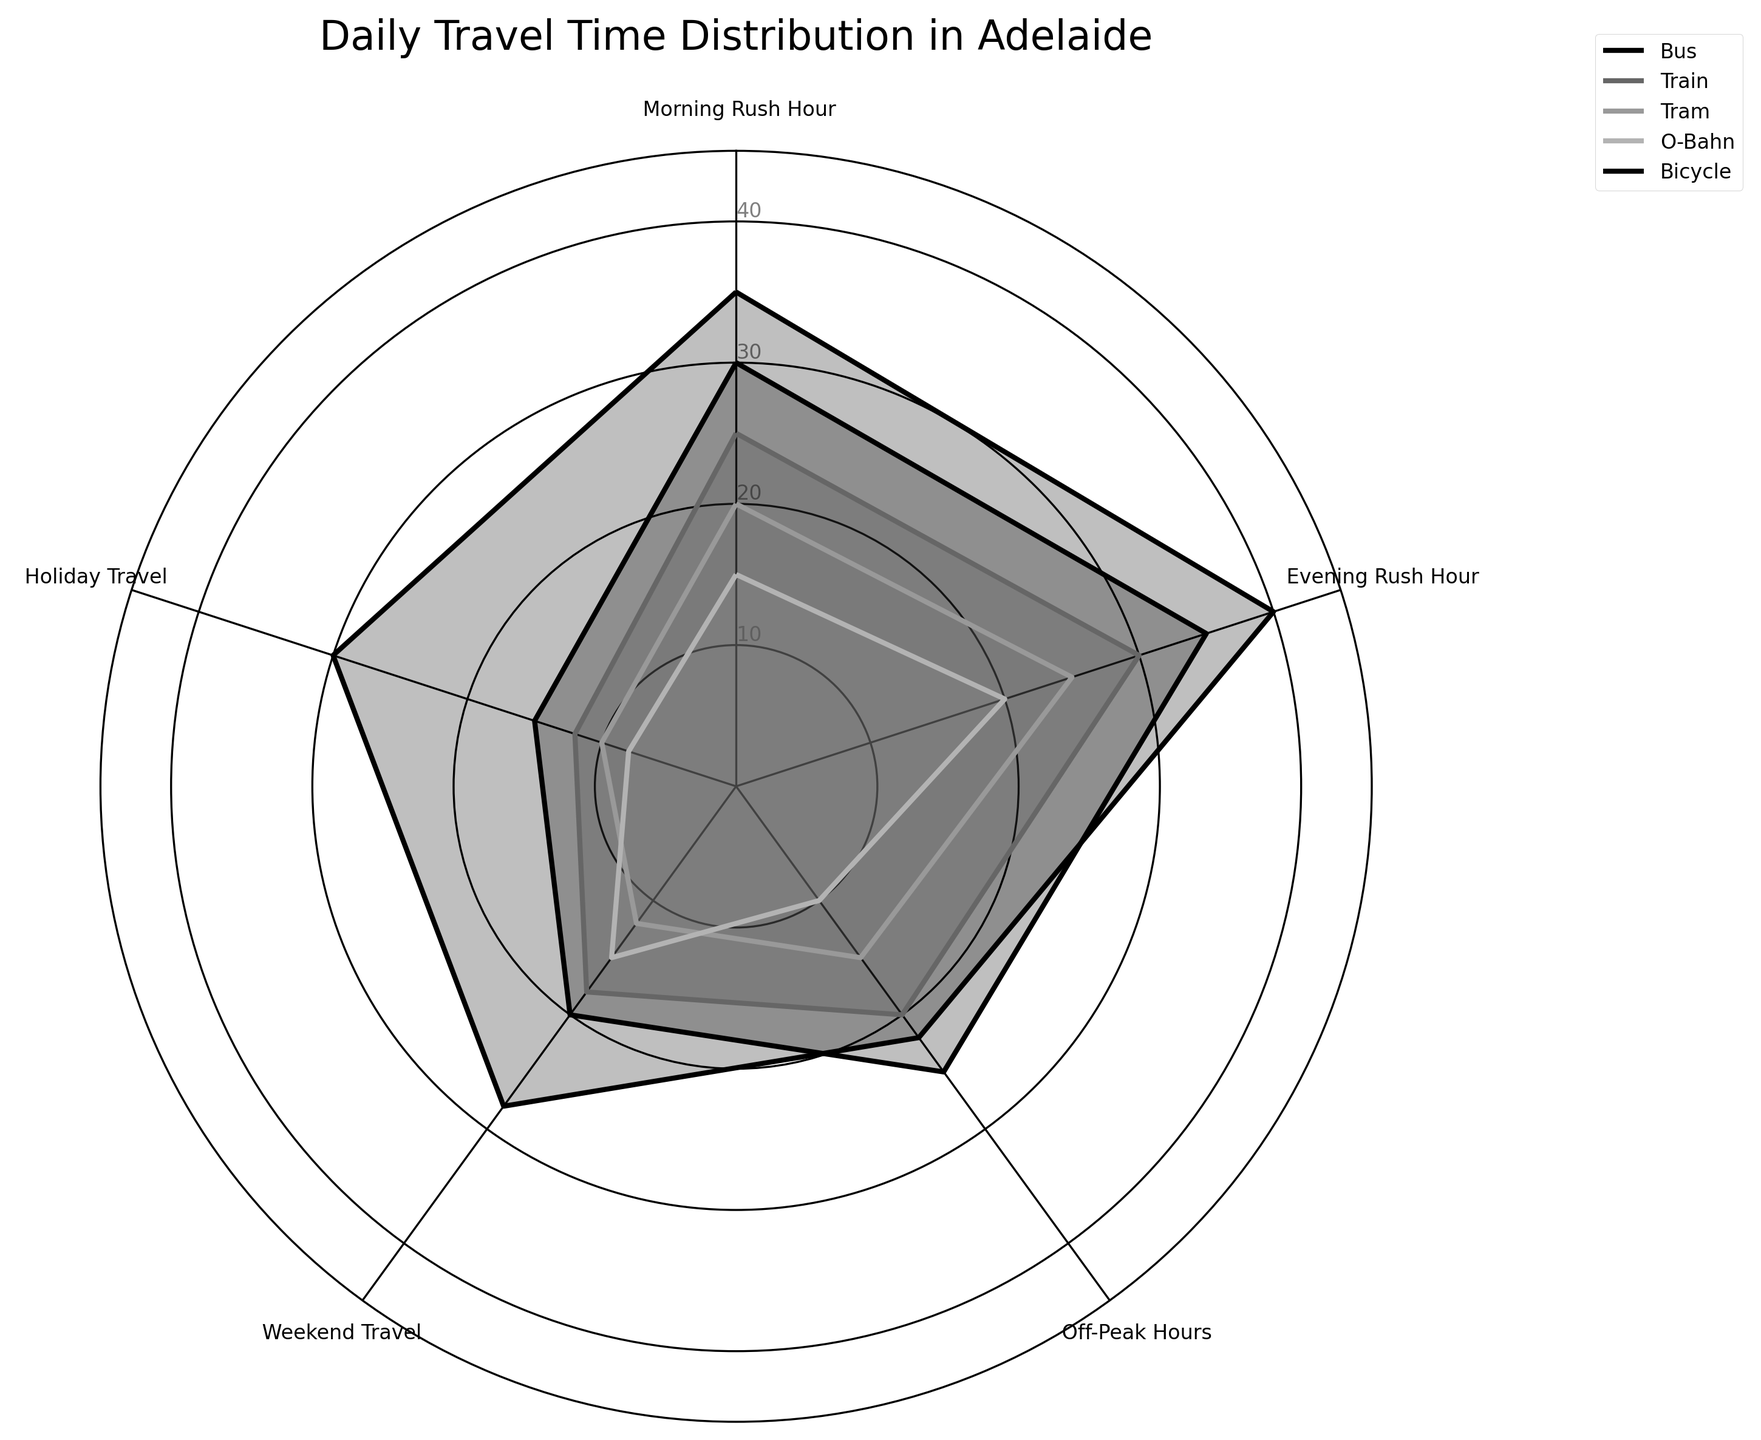What's the figure about? The title "Daily Travel Time Distribution in Adelaide" indicates the figure shows the distribution of travel times across different transport modes at various times
Answer: Daily Travel Time Distribution Which transport mode has the highest travel time during the Evening Rush Hour? By examining the "Evening Rush Hour" category, the Bicycle mode has the highest value of 40 minutes
Answer: Bicycle What is the average travel time for the Tram during Off-Peak Hours and Weekend Travel? The values are 15 minutes for Off-Peak Hours and 12 minutes for Weekend Travel. The average is (15 + 12) / 2 = 13.5 minutes
Answer: 13.5 minutes Which time category does the O-Bahn have the lowest travel time? By looking at the O-Bahn values, the lowest is 8 minutes during Holiday Travel
Answer: Holiday Travel Compare the travel times of Bus and Train during the Morning Rush Hour. Which one is higher? The Bus travel time is 30 minutes, and the Train travel time is 25 minutes during the Morning Rush Hour. Therefore, the Bus is higher
Answer: Bus During which time category does the Bicycle travel time exceed all other transport modes? In the Evening Rush Hour category, the Bicycle travel time of 40 minutes is higher than all other transport modes
Answer: Evening Rush Hour In which time category is the variance in travel times across all transport modes the highest? The range can be observed from the figure's radial distances. Evening Rush Hour values range from 20 (O-Bahn) to 40 (Bicycle), thus the highest variance is in the Evening Rush Hour
Answer: Evening Rush Hour What is the total travel time for the Train across all categories? Adding Train values: 25 (Morning) + 30 (Evening) + 20 (Off-Peak) + 18 (Weekend) + 12 (Holiday) = 105
Answer: 105 minutes Which transport mode generally shows the least variation in travel time across different categories? Observing the plot, O-Bahn has the smallest range of values from 8 to 20 minutes, indicating the least variation
Answer: O-Bahn 